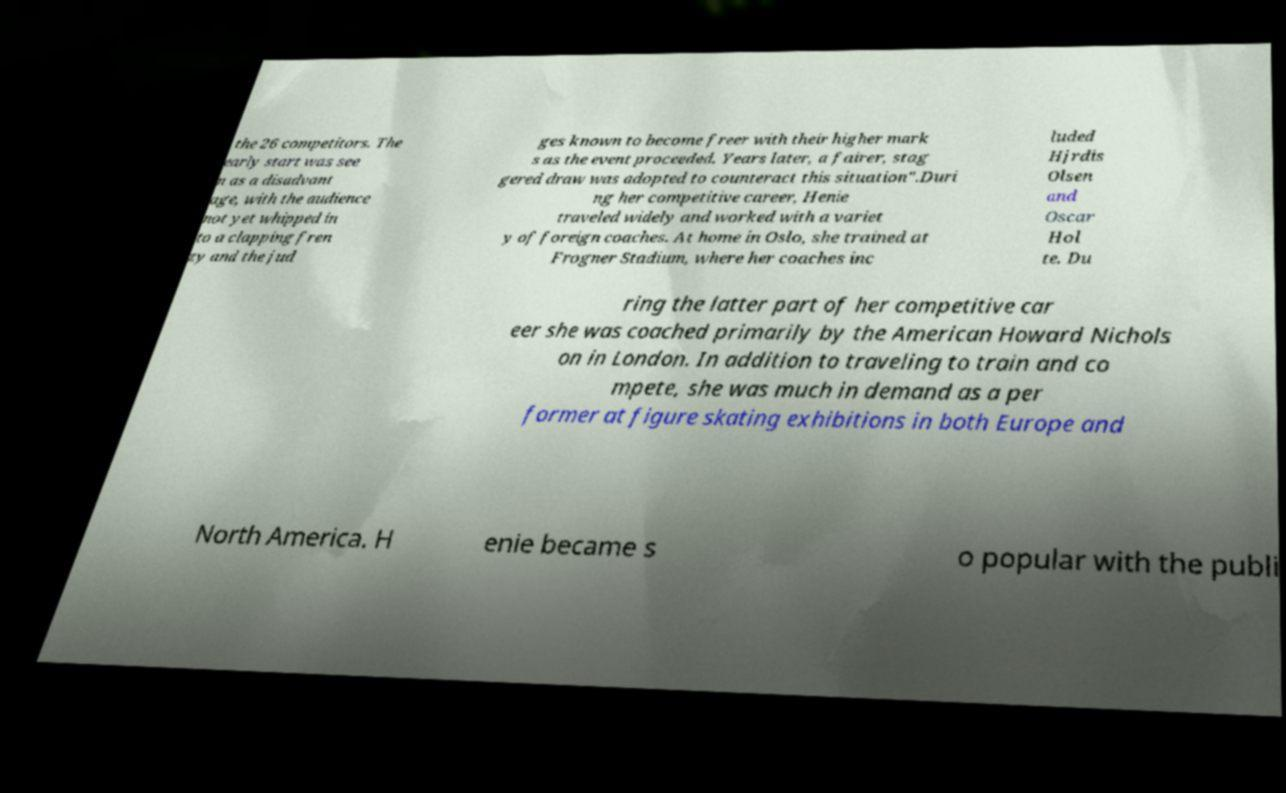Can you accurately transcribe the text from the provided image for me? the 26 competitors. The early start was see n as a disadvant age, with the audience not yet whipped in to a clapping fren zy and the jud ges known to become freer with their higher mark s as the event proceeded. Years later, a fairer, stag gered draw was adopted to counteract this situation".Duri ng her competitive career, Henie traveled widely and worked with a variet y of foreign coaches. At home in Oslo, she trained at Frogner Stadium, where her coaches inc luded Hjrdis Olsen and Oscar Hol te. Du ring the latter part of her competitive car eer she was coached primarily by the American Howard Nichols on in London. In addition to traveling to train and co mpete, she was much in demand as a per former at figure skating exhibitions in both Europe and North America. H enie became s o popular with the publi 